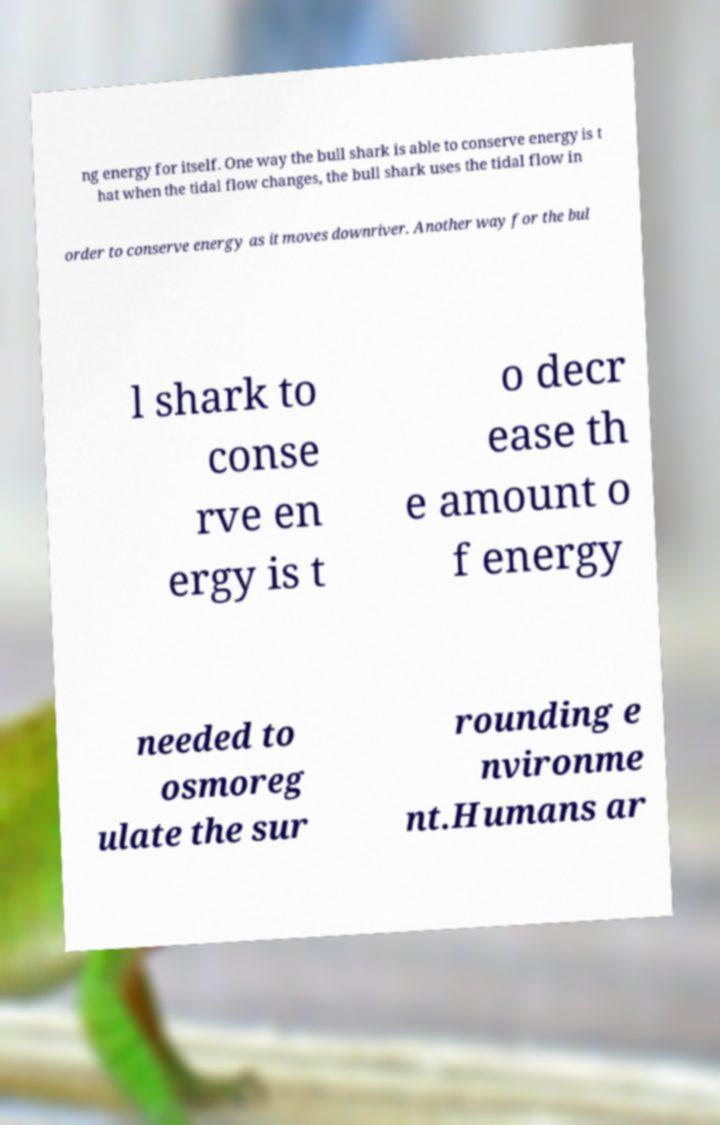Could you assist in decoding the text presented in this image and type it out clearly? ng energy for itself. One way the bull shark is able to conserve energy is t hat when the tidal flow changes, the bull shark uses the tidal flow in order to conserve energy as it moves downriver. Another way for the bul l shark to conse rve en ergy is t o decr ease th e amount o f energy needed to osmoreg ulate the sur rounding e nvironme nt.Humans ar 